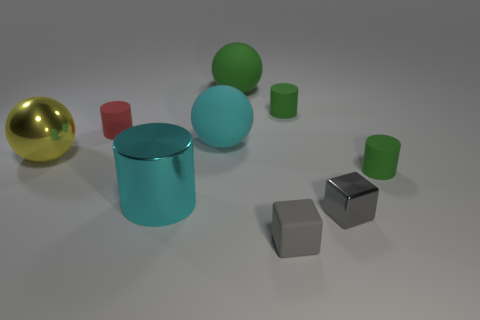There is a small cylinder on the left side of the big green object; is it the same color as the metal object to the left of the large cyan shiny cylinder?
Your answer should be very brief. No. Is the number of red cylinders greater than the number of small purple balls?
Provide a short and direct response. Yes. How many shiny cylinders are the same color as the large metallic sphere?
Provide a succinct answer. 0. There is a big metallic object that is the same shape as the red rubber thing; what color is it?
Ensure brevity in your answer.  Cyan. There is a cylinder that is in front of the shiny sphere and right of the matte block; what is its material?
Offer a terse response. Rubber. Is the big thing in front of the yellow ball made of the same material as the small cylinder left of the big cyan cylinder?
Ensure brevity in your answer.  No. How big is the metal ball?
Offer a terse response. Large. What is the size of the green rubber thing that is the same shape as the yellow object?
Your answer should be very brief. Large. There is a large shiny cylinder; how many matte cylinders are behind it?
Provide a short and direct response. 3. There is a cylinder in front of the green cylinder that is in front of the small red matte cylinder; what color is it?
Your response must be concise. Cyan. 